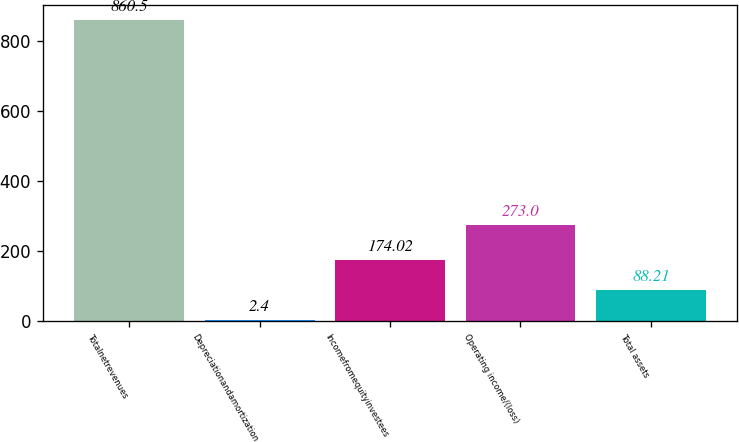Convert chart. <chart><loc_0><loc_0><loc_500><loc_500><bar_chart><fcel>Totalnetrevenues<fcel>Depreciationandamortization<fcel>Incomefromequityinvestees<fcel>Operating income/(loss)<fcel>Total assets<nl><fcel>860.5<fcel>2.4<fcel>174.02<fcel>273<fcel>88.21<nl></chart> 